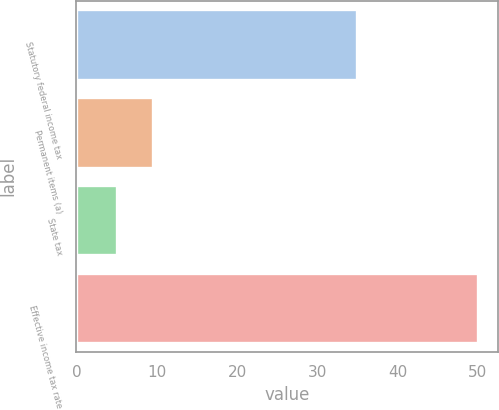<chart> <loc_0><loc_0><loc_500><loc_500><bar_chart><fcel>Statutory federal income tax<fcel>Permanent items (a)<fcel>State tax<fcel>Effective income tax rate<nl><fcel>35<fcel>9.5<fcel>5<fcel>50<nl></chart> 